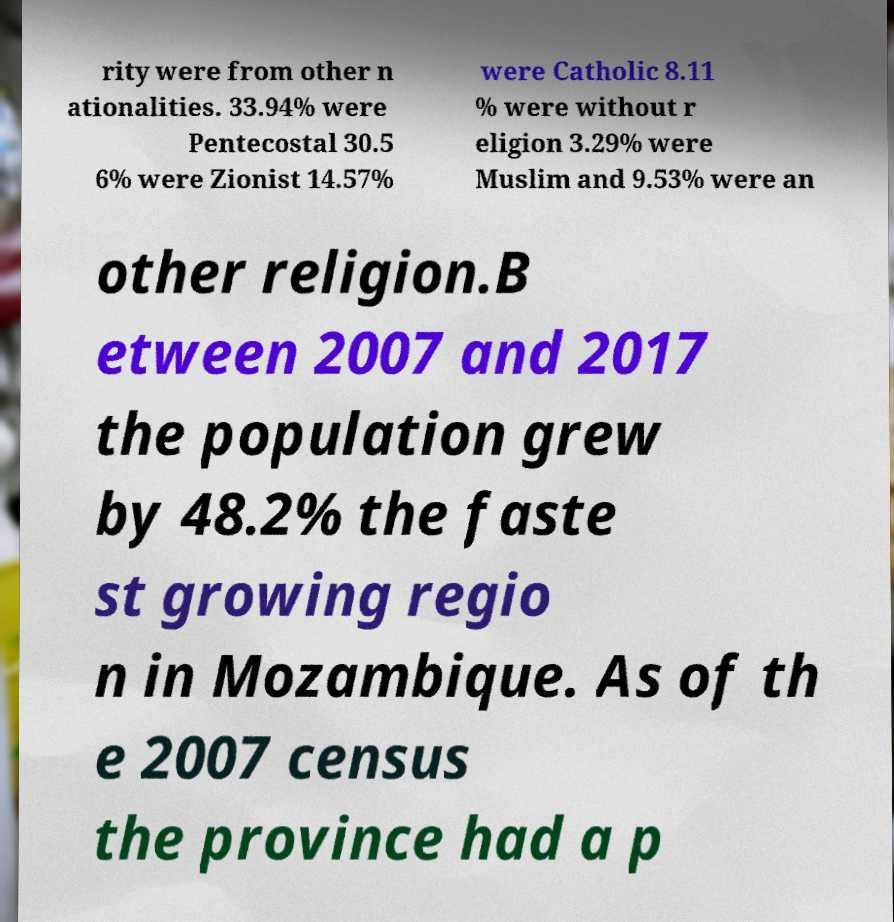Can you read and provide the text displayed in the image?This photo seems to have some interesting text. Can you extract and type it out for me? rity were from other n ationalities. 33.94% were Pentecostal 30.5 6% were Zionist 14.57% were Catholic 8.11 % were without r eligion 3.29% were Muslim and 9.53% were an other religion.B etween 2007 and 2017 the population grew by 48.2% the faste st growing regio n in Mozambique. As of th e 2007 census the province had a p 